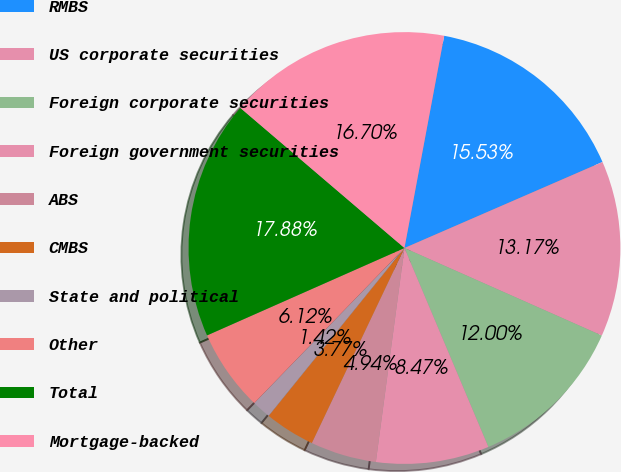<chart> <loc_0><loc_0><loc_500><loc_500><pie_chart><fcel>RMBS<fcel>US corporate securities<fcel>Foreign corporate securities<fcel>Foreign government securities<fcel>ABS<fcel>CMBS<fcel>State and political<fcel>Other<fcel>Total<fcel>Mortgage-backed<nl><fcel>15.53%<fcel>13.17%<fcel>12.0%<fcel>8.47%<fcel>4.94%<fcel>3.77%<fcel>1.42%<fcel>6.12%<fcel>17.88%<fcel>16.7%<nl></chart> 